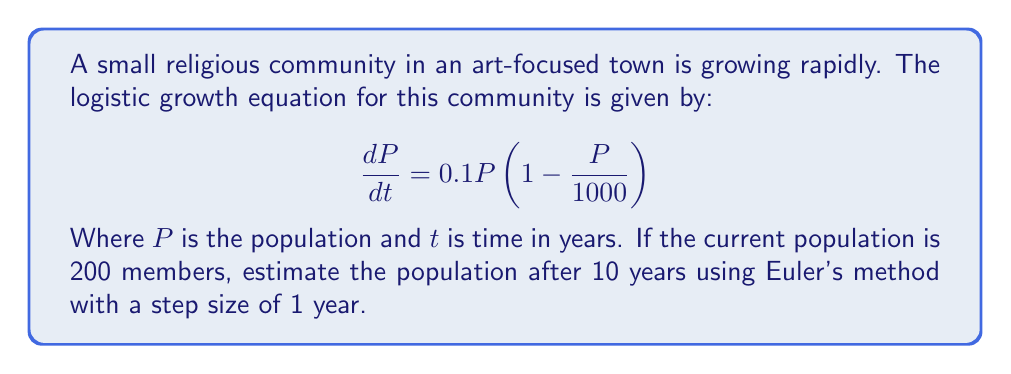Help me with this question. To solve this problem, we'll use Euler's method to approximate the population growth over time. Euler's method is an iterative approach that estimates the solution to differential equations.

The logistic equation is given by:
$$\frac{dP}{dt} = 0.1P(1 - \frac{P}{1000})$$

Euler's method formula:
$$P_{n+1} = P_n + h \cdot f(t_n, P_n)$$

Where:
- $P_n$ is the population at step $n$
- $h$ is the step size (1 year in this case)
- $f(t_n, P_n)$ is the rate of change given by our logistic equation

Let's calculate step by step:

1) Initial conditions: $P_0 = 200$, $h = 1$, $n = 10$ (for 10 years)

2) For each step, we calculate:
   $$P_{n+1} = P_n + 1 \cdot (0.1P_n(1 - \frac{P_n}{1000}))$$

3) Calculations:
   Year 1: $P_1 = 200 + 0.1 \cdot 200 \cdot (1 - \frac{200}{1000}) = 216$
   Year 2: $P_2 = 216 + 0.1 \cdot 216 \cdot (1 - \frac{216}{1000}) = 232.70$
   Year 3: $P_3 = 232.70 + 0.1 \cdot 232.70 \cdot (1 - \frac{232.70}{1000}) = 249.98$
   ...
   Year 10: $P_{10} = 426.83 + 0.1 \cdot 426.83 \cdot (1 - \frac{426.83}{1000}) = 451.18$

4) After 10 iterations, we arrive at the final population estimate.
Answer: The estimated population of the religious community after 10 years is approximately 451 members. 